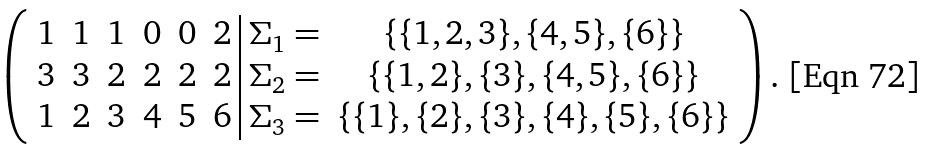<formula> <loc_0><loc_0><loc_500><loc_500>\left ( \begin{array} { c c c c c c | l c } 1 & 1 & 1 & 0 & 0 & 2 & \Sigma _ { 1 } = & \{ \{ 1 , 2 , 3 \} , \{ 4 , 5 \} , \{ 6 \} \} \\ 3 & 3 & 2 & 2 & 2 & 2 & \Sigma _ { 2 } = & \{ \{ 1 , 2 \} , \{ 3 \} , \{ 4 , 5 \} , \{ 6 \} \} \\ 1 & 2 & 3 & 4 & 5 & 6 & \Sigma _ { 3 } = & \{ \{ 1 \} , \{ 2 \} , \{ 3 \} , \{ 4 \} , \{ 5 \} , \{ 6 \} \} \end{array} \right ) .</formula> 